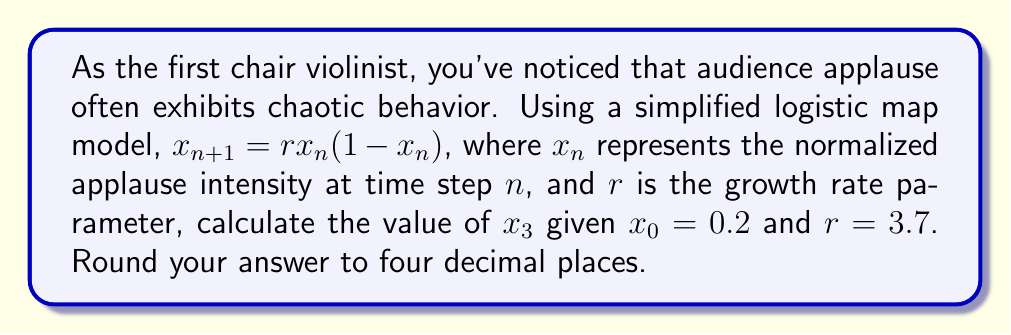What is the answer to this math problem? To solve this problem, we'll use the logistic map equation iteratively:

1) First, we calculate $x_1$ using $x_0 = 0.2$ and $r = 3.7$:
   $$x_1 = 3.7 * 0.2 * (1 - 0.2) = 3.7 * 0.2 * 0.8 = 0.592$$

2) Now we use $x_1 = 0.592$ to calculate $x_2$:
   $$x_2 = 3.7 * 0.592 * (1 - 0.592) = 3.7 * 0.592 * 0.408 = 0.8929344$$

3) Finally, we use $x_2 = 0.8929344$ to calculate $x_3$:
   $$x_3 = 3.7 * 0.8929344 * (1 - 0.8929344) = 3.7 * 0.8929344 * 0.1070656 = 0.3540$$

4) Rounding to four decimal places: 0.3540

This demonstrates how the applause intensity changes chaotically over time, which is characteristic of the logistic map in certain parameter ranges.
Answer: 0.3540 